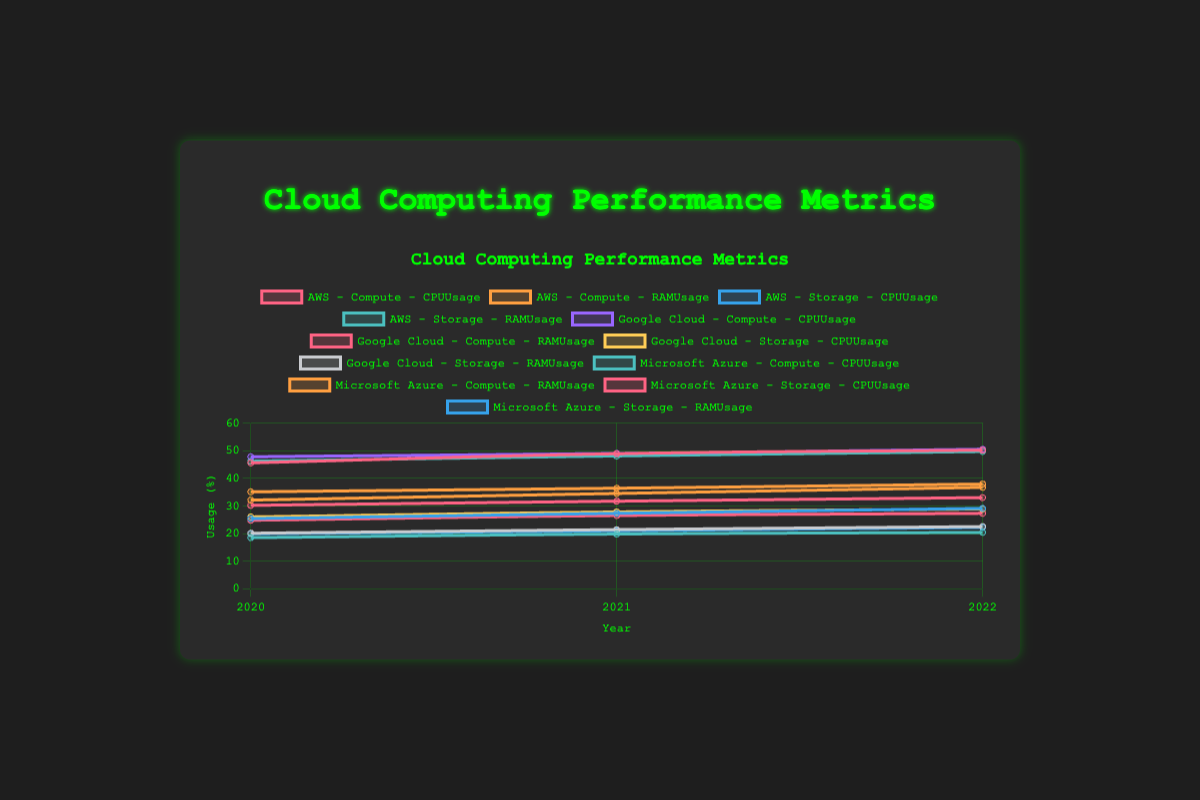Which service type had the highest CPU usage for AWS in 2022? Look at the line chart for AWS in 2022 and compare the CPU usage values between "Compute" and "Storage" service types. The CPU usage for "Compute" is higher.
Answer: Compute How did Google Cloud's RAM usage for Compute services change from 2020 to 2022? Observe the trend line for Google Cloud's Compute service RAM usage between 2020 and 2022. It started at 30.2% in 2020 and increased to 33.0% in 2022.
Answer: It increased By how much did Microsoft Azure's Storage CPU usage increase from 2020 to 2022? Compare the CPU usage for Microsoft Azure's Storage service in 2020 (24.8%) and 2022 (27.3%). Calculate the difference: 27.3% - 24.8% = 2.5%.
Answer: 2.5% Which provider had the lowest RAM usage for Compute services in 2021? Compare the RAM usage for all three providers (AWS, Google Cloud, Microsoft Azure) for Compute services in 2021. Microsoft Azure had the highest RAM usage at 36.4%, followed by AWS at 34.5% and Google Cloud at 31.7%.
Answer: Google Cloud What is the average CPU usage for AWS Storage services over the three years displayed? Add the CPU usage for AWS Storage from 2020 to 2022 (25.4%, 27.3%, 29.1%) and divide by 3 to find the average. (25.4 + 27.3 + 29.1) / 3 = 27.27%
Answer: 27.27% Compare the RAM usage trends for Google Cloud's Compute and Storage services over the years. Observe the trend lines for RAM usage in Google Cloud's Compute and Storage services from 2020 to 2022. Both are increasing, but Compute starts from a lower value in 2020 (30.2%) compared to Storage (20.1%). By 2022, both have increased but the gap remains similar (Compute at 33.0%, Storage at 22.5%).
Answer: Both are increasing, Compute has a higher increase For which provider and service type category does the CPU usage increase the least from 2020 to 2022? Look at the CPU usage changes for all providers and service types. AWS Storage increases from 25.4% to 29.1% (+3.7%), Google Cloud Storage from 26.0% to 28.9% (+2.9%), and Microsoft Azure Storage from 24.8% to 27.3% (+2.5%).
Answer: Microsoft Azure Storage Which service type and provider combination had the highest overall RAM usage in 2020? Compare RAM usage for all provider-service combinations in 2020. Microsoft Azure Compute had 35.1%, which is the highest among all.
Answer: Microsoft Azure Compute What is the combined CPU usage for Google Cloud's services in 2021? Add the CPU usage for both Google Cloud Compute (49.0%) and Storage (27.8%) in 2021. 49.0% + 27.8% = 76.8%
Answer: 76.8% Which provider had the most consistent RAM usage for Compute services over the years? Examine the RAM usage trend lines for Compute services of all providers. Google Cloud's RAM usage for Compute services shows the least variation between the years from 2020 (30.2%) to 2022 (33.0%).
Answer: Google Cloud 